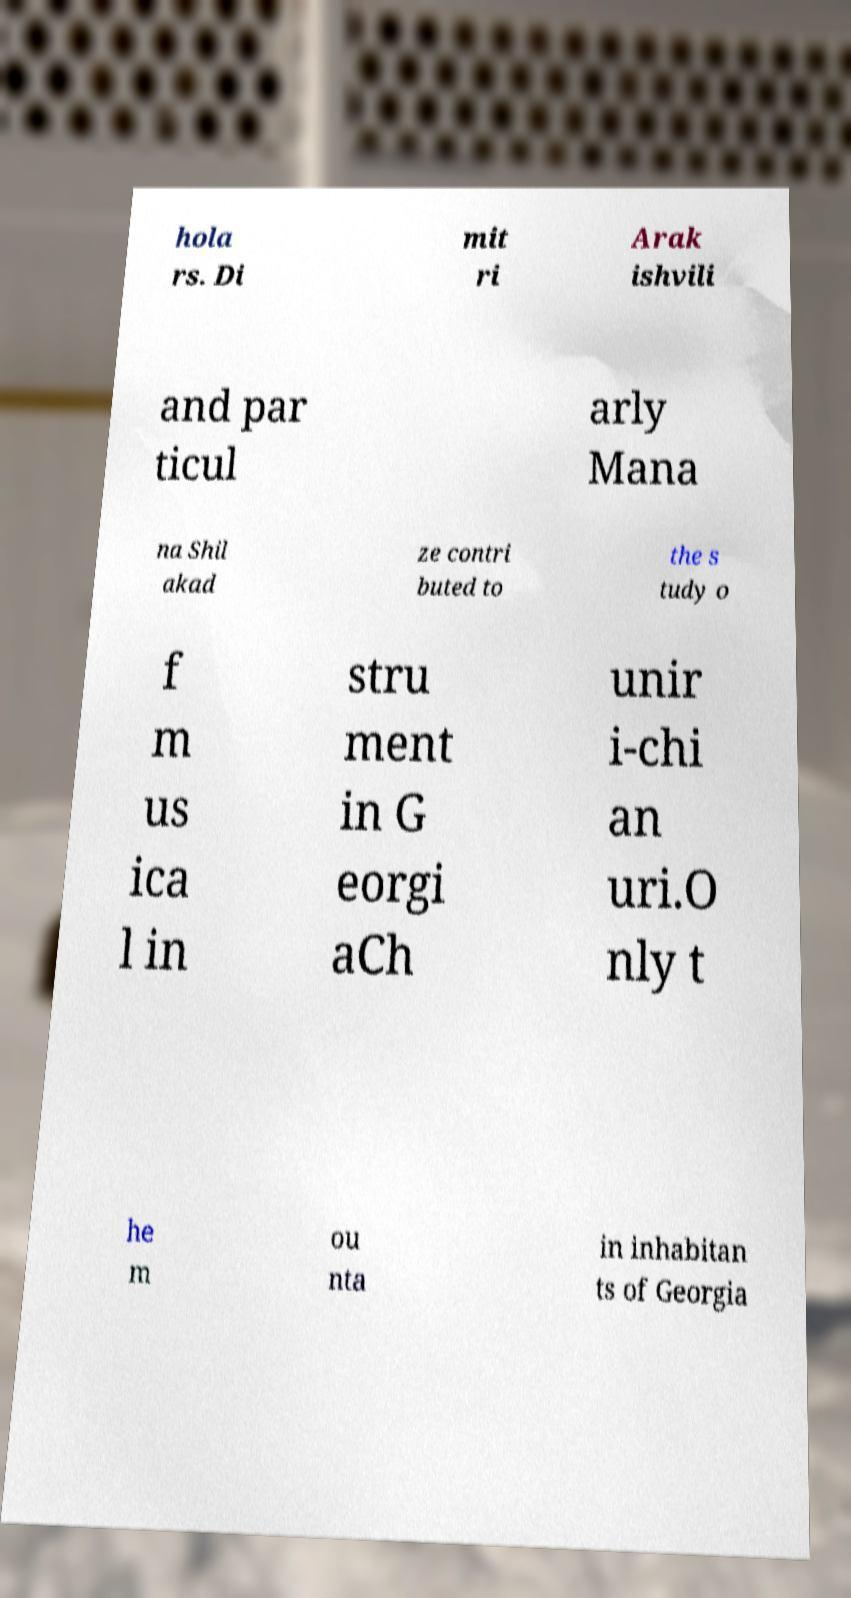Could you assist in decoding the text presented in this image and type it out clearly? hola rs. Di mit ri Arak ishvili and par ticul arly Mana na Shil akad ze contri buted to the s tudy o f m us ica l in stru ment in G eorgi aCh unir i-chi an uri.O nly t he m ou nta in inhabitan ts of Georgia 